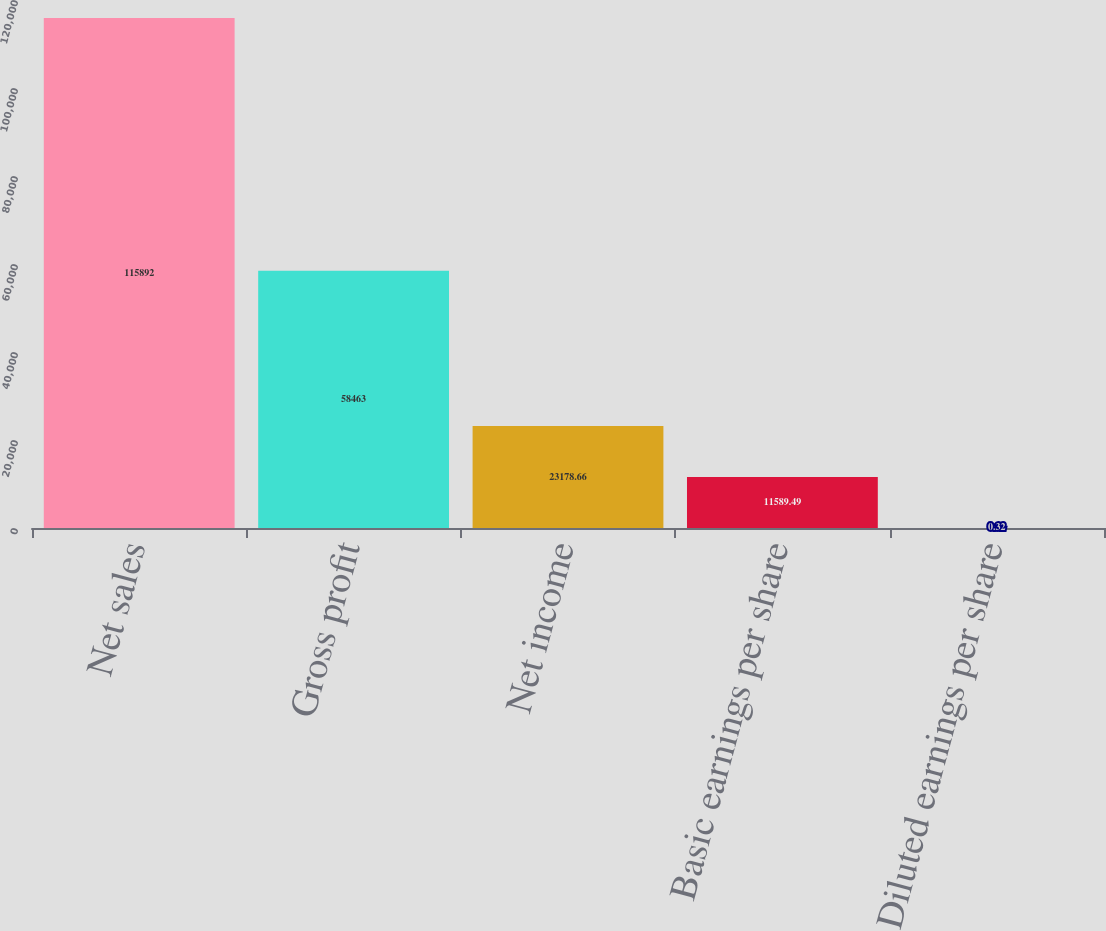Convert chart. <chart><loc_0><loc_0><loc_500><loc_500><bar_chart><fcel>Net sales<fcel>Gross profit<fcel>Net income<fcel>Basic earnings per share<fcel>Diluted earnings per share<nl><fcel>115892<fcel>58463<fcel>23178.7<fcel>11589.5<fcel>0.32<nl></chart> 